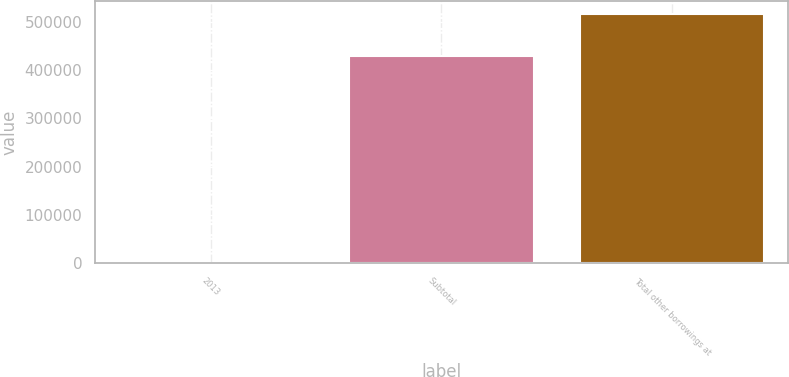Convert chart to OTSL. <chart><loc_0><loc_0><loc_500><loc_500><bar_chart><fcel>2013<fcel>Subtotal<fcel>Total other borrowings at<nl><fcel>1238<fcel>429167<fcel>515767<nl></chart> 